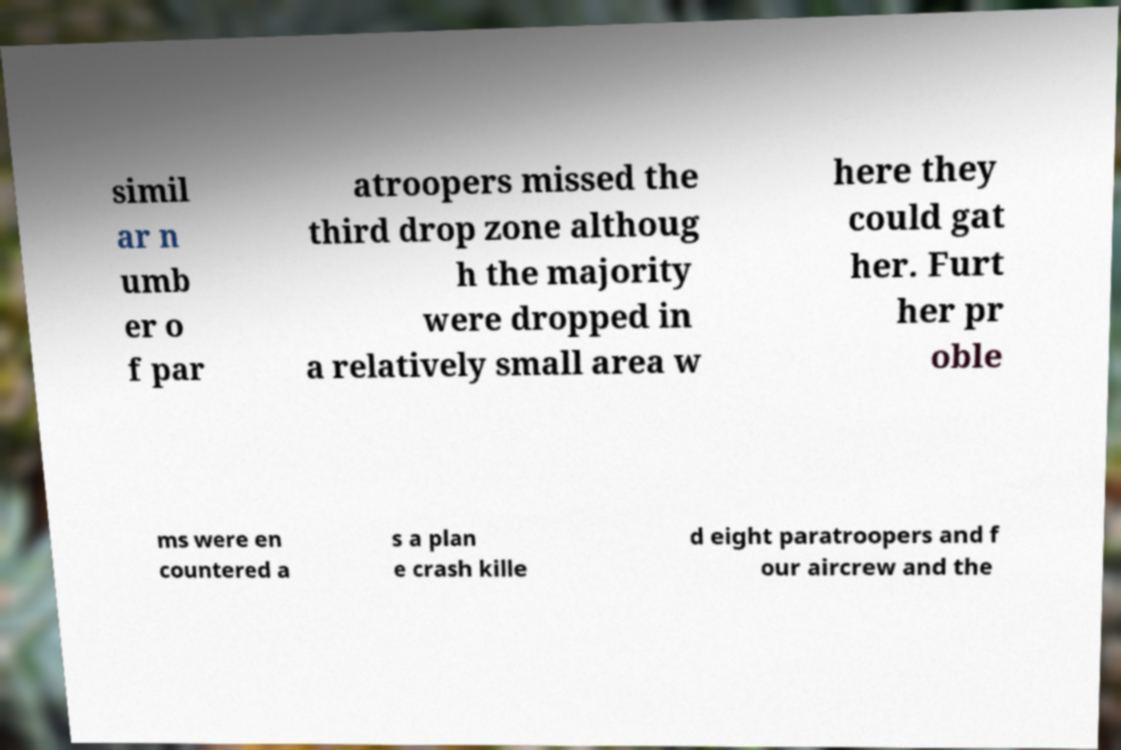There's text embedded in this image that I need extracted. Can you transcribe it verbatim? simil ar n umb er o f par atroopers missed the third drop zone althoug h the majority were dropped in a relatively small area w here they could gat her. Furt her pr oble ms were en countered a s a plan e crash kille d eight paratroopers and f our aircrew and the 